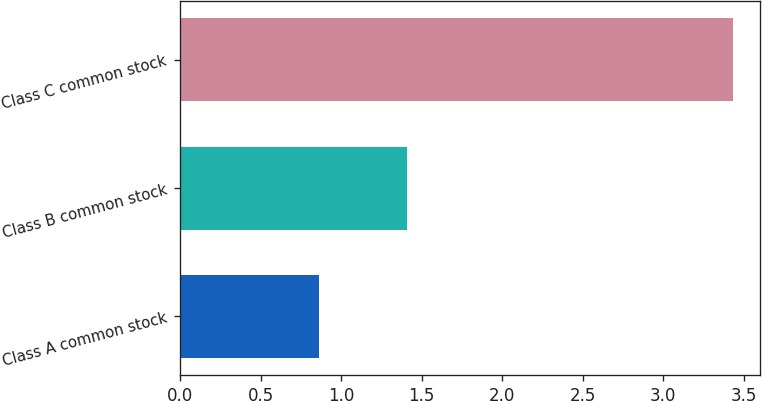Convert chart. <chart><loc_0><loc_0><loc_500><loc_500><bar_chart><fcel>Class A common stock<fcel>Class B common stock<fcel>Class C common stock<nl><fcel>0.86<fcel>1.41<fcel>3.43<nl></chart> 